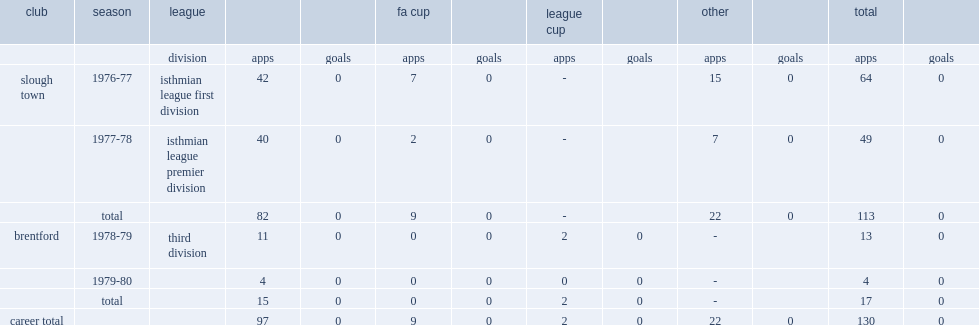What was the number of appearances made by trevor porter for slough town totally. 113.0. 